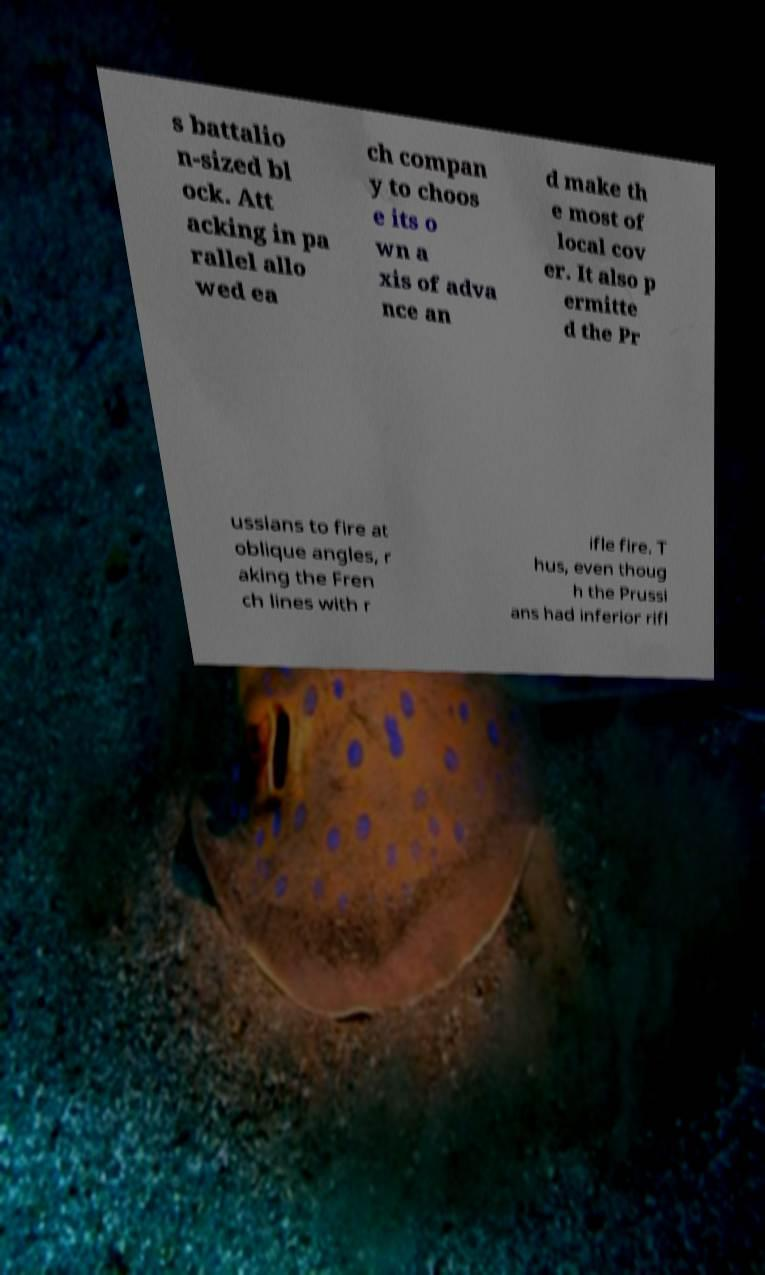I need the written content from this picture converted into text. Can you do that? s battalio n-sized bl ock. Att acking in pa rallel allo wed ea ch compan y to choos e its o wn a xis of adva nce an d make th e most of local cov er. It also p ermitte d the Pr ussians to fire at oblique angles, r aking the Fren ch lines with r ifle fire. T hus, even thoug h the Prussi ans had inferior rifl 